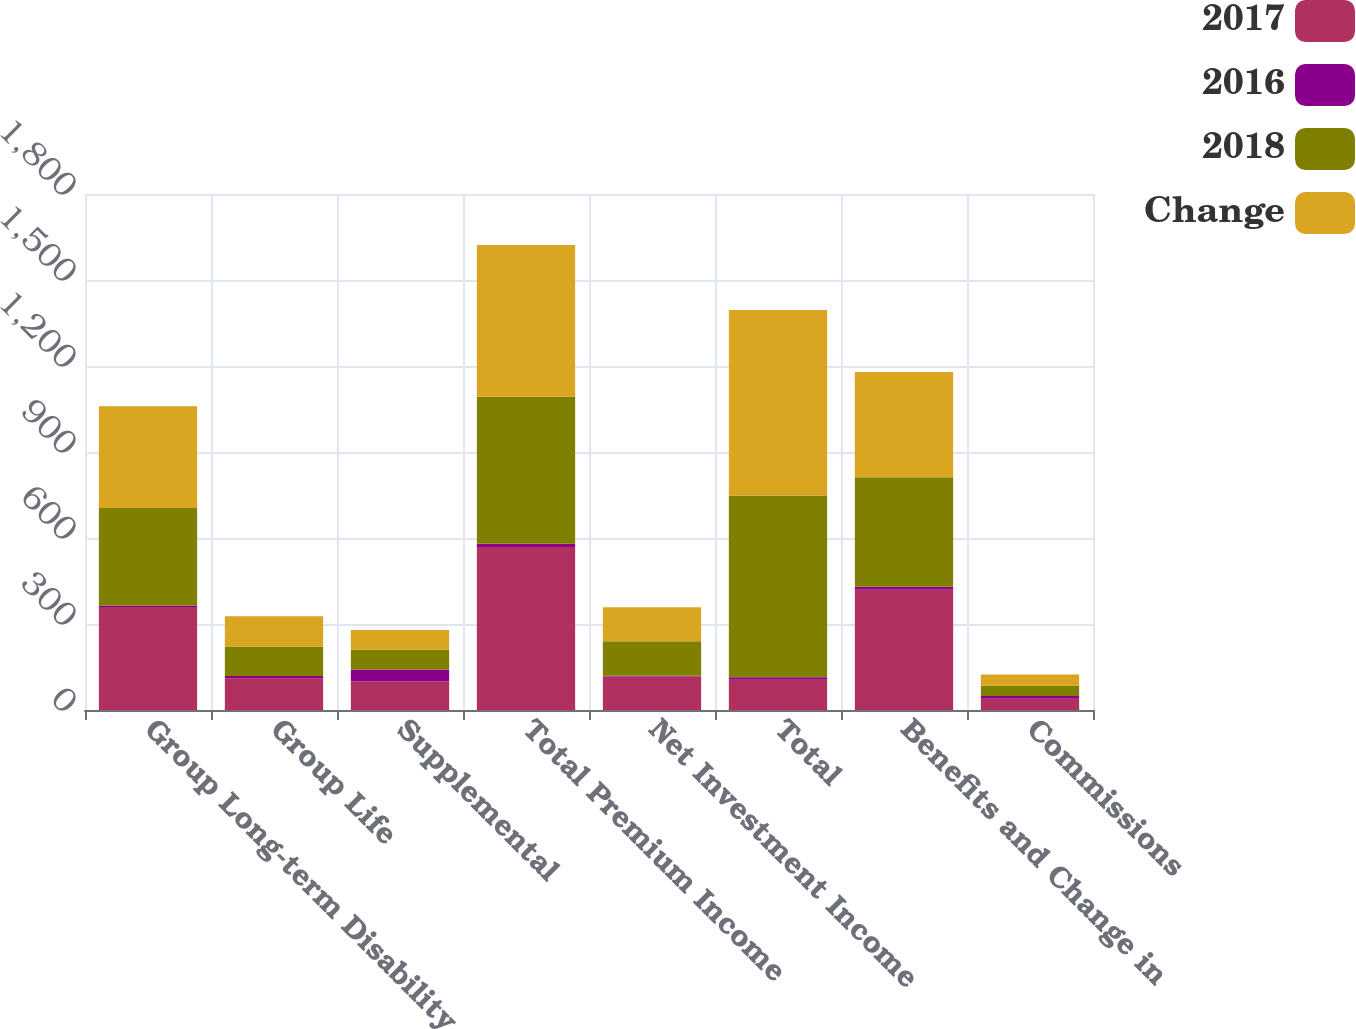<chart> <loc_0><loc_0><loc_500><loc_500><stacked_bar_chart><ecel><fcel>Group Long-term Disability<fcel>Group Life<fcel>Supplemental<fcel>Total Premium Income<fcel>Net Investment Income<fcel>Total<fcel>Benefits and Change in<fcel>Commissions<nl><fcel>2017<fcel>358.9<fcel>110.8<fcel>99.1<fcel>568.8<fcel>117.2<fcel>105.7<fcel>419.8<fcel>39.1<nl><fcel>2016<fcel>5.5<fcel>7.5<fcel>42.4<fcel>10.9<fcel>2.5<fcel>8.3<fcel>9.9<fcel>10.1<nl><fcel>2018<fcel>340.3<fcel>103.1<fcel>69.6<fcel>513<fcel>120.2<fcel>633.9<fcel>381.9<fcel>35.5<nl><fcel>Change<fcel>355.2<fcel>105.7<fcel>68.4<fcel>529.3<fcel>118.1<fcel>647.6<fcel>367.4<fcel>38.9<nl></chart> 